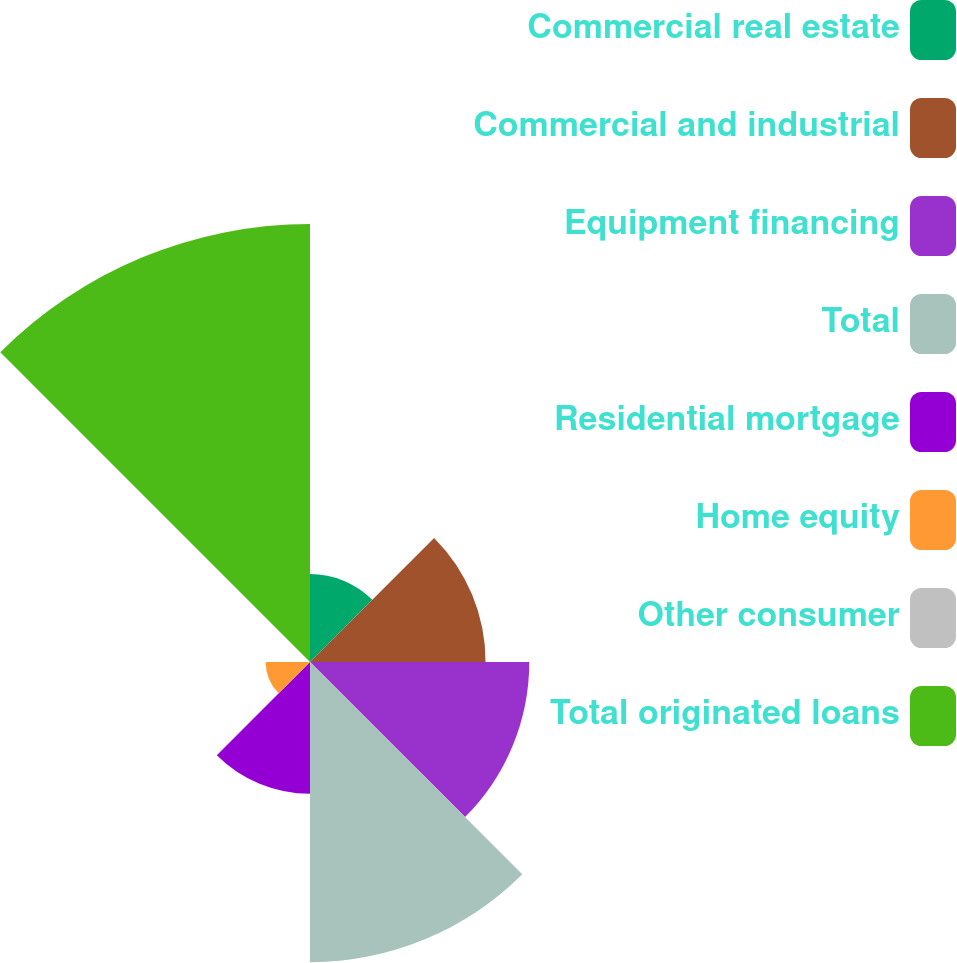Convert chart. <chart><loc_0><loc_0><loc_500><loc_500><pie_chart><fcel>Commercial real estate<fcel>Commercial and industrial<fcel>Equipment financing<fcel>Total<fcel>Residential mortgage<fcel>Home equity<fcel>Other consumer<fcel>Total originated loans<nl><fcel>6.3%<fcel>12.56%<fcel>15.69%<fcel>21.48%<fcel>9.43%<fcel>3.17%<fcel>0.04%<fcel>31.34%<nl></chart> 